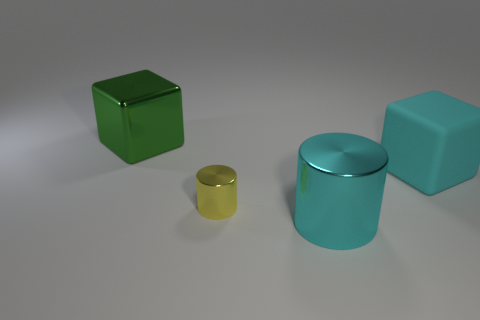Is the yellow cylinder made of the same material as the block that is right of the small metallic cylinder?
Offer a terse response. No. Is there a matte object that is to the left of the cyan thing that is in front of the large cyan matte cube?
Provide a succinct answer. No. There is another thing that is the same shape as the cyan rubber object; what is its material?
Provide a succinct answer. Metal. There is a big cyan object in front of the large cyan block; what number of yellow shiny objects are behind it?
Your answer should be very brief. 1. Are there any other things that are the same color as the large rubber block?
Your answer should be compact. Yes. What number of things are either yellow metallic cylinders or objects that are on the left side of the large metal cylinder?
Give a very brief answer. 2. The tiny yellow cylinder that is on the left side of the cube in front of the block that is behind the large cyan cube is made of what material?
Your answer should be very brief. Metal. What size is the green cube that is the same material as the tiny cylinder?
Make the answer very short. Large. There is a big shiny thing that is on the left side of the large metallic cylinder that is left of the matte object; what is its color?
Ensure brevity in your answer.  Green. What number of yellow things have the same material as the green block?
Your response must be concise. 1. 